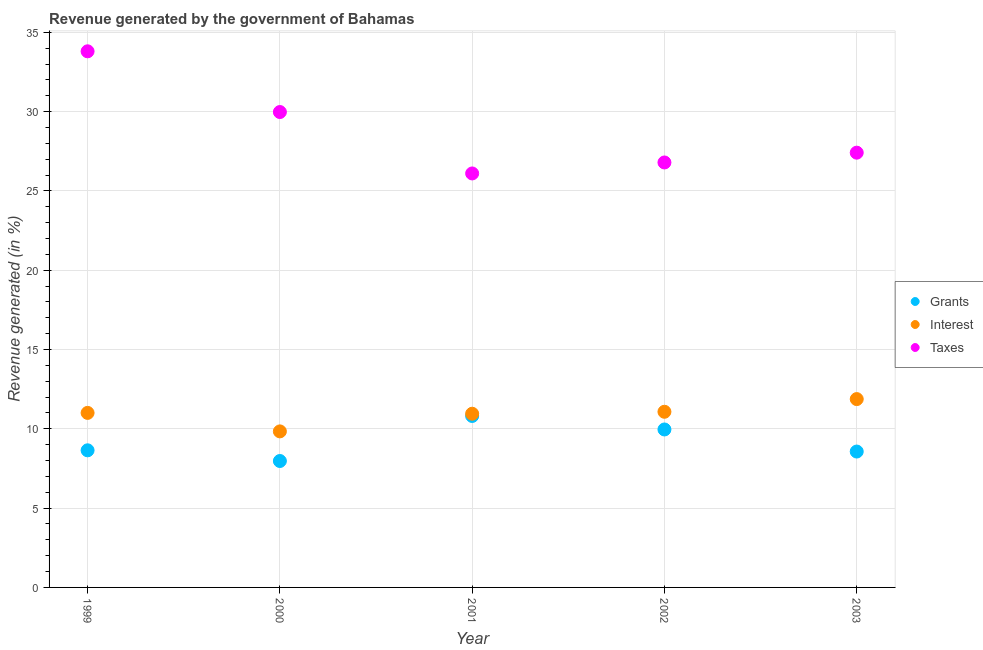What is the percentage of revenue generated by taxes in 2002?
Keep it short and to the point. 26.79. Across all years, what is the maximum percentage of revenue generated by grants?
Offer a terse response. 10.81. Across all years, what is the minimum percentage of revenue generated by grants?
Give a very brief answer. 7.97. What is the total percentage of revenue generated by interest in the graph?
Your answer should be very brief. 54.74. What is the difference between the percentage of revenue generated by taxes in 1999 and that in 2001?
Your answer should be very brief. 7.7. What is the difference between the percentage of revenue generated by grants in 2003 and the percentage of revenue generated by interest in 2001?
Ensure brevity in your answer.  -2.38. What is the average percentage of revenue generated by grants per year?
Your answer should be compact. 9.19. In the year 1999, what is the difference between the percentage of revenue generated by taxes and percentage of revenue generated by interest?
Your answer should be very brief. 22.8. In how many years, is the percentage of revenue generated by taxes greater than 13 %?
Keep it short and to the point. 5. What is the ratio of the percentage of revenue generated by interest in 1999 to that in 2003?
Make the answer very short. 0.93. Is the difference between the percentage of revenue generated by interest in 2001 and 2002 greater than the difference between the percentage of revenue generated by grants in 2001 and 2002?
Your response must be concise. No. What is the difference between the highest and the second highest percentage of revenue generated by taxes?
Ensure brevity in your answer.  3.83. What is the difference between the highest and the lowest percentage of revenue generated by interest?
Ensure brevity in your answer.  2.04. Is it the case that in every year, the sum of the percentage of revenue generated by grants and percentage of revenue generated by interest is greater than the percentage of revenue generated by taxes?
Offer a terse response. No. Does the percentage of revenue generated by interest monotonically increase over the years?
Offer a very short reply. No. How many years are there in the graph?
Keep it short and to the point. 5. What is the difference between two consecutive major ticks on the Y-axis?
Offer a terse response. 5. Are the values on the major ticks of Y-axis written in scientific E-notation?
Keep it short and to the point. No. Where does the legend appear in the graph?
Offer a terse response. Center right. How are the legend labels stacked?
Make the answer very short. Vertical. What is the title of the graph?
Make the answer very short. Revenue generated by the government of Bahamas. Does "Negligence towards kids" appear as one of the legend labels in the graph?
Ensure brevity in your answer.  No. What is the label or title of the X-axis?
Make the answer very short. Year. What is the label or title of the Y-axis?
Keep it short and to the point. Revenue generated (in %). What is the Revenue generated (in %) of Grants in 1999?
Offer a very short reply. 8.64. What is the Revenue generated (in %) in Interest in 1999?
Give a very brief answer. 11. What is the Revenue generated (in %) in Taxes in 1999?
Offer a terse response. 33.8. What is the Revenue generated (in %) of Grants in 2000?
Your answer should be very brief. 7.97. What is the Revenue generated (in %) in Interest in 2000?
Offer a terse response. 9.84. What is the Revenue generated (in %) in Taxes in 2000?
Ensure brevity in your answer.  29.97. What is the Revenue generated (in %) of Grants in 2001?
Offer a very short reply. 10.81. What is the Revenue generated (in %) of Interest in 2001?
Provide a succinct answer. 10.95. What is the Revenue generated (in %) of Taxes in 2001?
Your response must be concise. 26.1. What is the Revenue generated (in %) in Grants in 2002?
Offer a terse response. 9.96. What is the Revenue generated (in %) of Interest in 2002?
Provide a short and direct response. 11.07. What is the Revenue generated (in %) in Taxes in 2002?
Make the answer very short. 26.79. What is the Revenue generated (in %) of Grants in 2003?
Provide a succinct answer. 8.57. What is the Revenue generated (in %) of Interest in 2003?
Keep it short and to the point. 11.87. What is the Revenue generated (in %) in Taxes in 2003?
Provide a succinct answer. 27.41. Across all years, what is the maximum Revenue generated (in %) of Grants?
Ensure brevity in your answer.  10.81. Across all years, what is the maximum Revenue generated (in %) in Interest?
Your answer should be compact. 11.87. Across all years, what is the maximum Revenue generated (in %) of Taxes?
Keep it short and to the point. 33.8. Across all years, what is the minimum Revenue generated (in %) of Grants?
Your answer should be very brief. 7.97. Across all years, what is the minimum Revenue generated (in %) in Interest?
Your response must be concise. 9.84. Across all years, what is the minimum Revenue generated (in %) in Taxes?
Make the answer very short. 26.1. What is the total Revenue generated (in %) of Grants in the graph?
Give a very brief answer. 45.95. What is the total Revenue generated (in %) of Interest in the graph?
Ensure brevity in your answer.  54.74. What is the total Revenue generated (in %) in Taxes in the graph?
Your answer should be compact. 144.08. What is the difference between the Revenue generated (in %) in Grants in 1999 and that in 2000?
Your answer should be compact. 0.67. What is the difference between the Revenue generated (in %) in Interest in 1999 and that in 2000?
Provide a short and direct response. 1.17. What is the difference between the Revenue generated (in %) of Taxes in 1999 and that in 2000?
Your answer should be very brief. 3.83. What is the difference between the Revenue generated (in %) of Grants in 1999 and that in 2001?
Provide a succinct answer. -2.17. What is the difference between the Revenue generated (in %) in Interest in 1999 and that in 2001?
Provide a short and direct response. 0.05. What is the difference between the Revenue generated (in %) of Taxes in 1999 and that in 2001?
Give a very brief answer. 7.7. What is the difference between the Revenue generated (in %) of Grants in 1999 and that in 2002?
Offer a terse response. -1.31. What is the difference between the Revenue generated (in %) in Interest in 1999 and that in 2002?
Your answer should be very brief. -0.07. What is the difference between the Revenue generated (in %) in Taxes in 1999 and that in 2002?
Offer a very short reply. 7.01. What is the difference between the Revenue generated (in %) in Grants in 1999 and that in 2003?
Your answer should be compact. 0.08. What is the difference between the Revenue generated (in %) of Interest in 1999 and that in 2003?
Keep it short and to the point. -0.87. What is the difference between the Revenue generated (in %) in Taxes in 1999 and that in 2003?
Your answer should be very brief. 6.39. What is the difference between the Revenue generated (in %) in Grants in 2000 and that in 2001?
Offer a very short reply. -2.84. What is the difference between the Revenue generated (in %) in Interest in 2000 and that in 2001?
Ensure brevity in your answer.  -1.11. What is the difference between the Revenue generated (in %) in Taxes in 2000 and that in 2001?
Provide a succinct answer. 3.87. What is the difference between the Revenue generated (in %) of Grants in 2000 and that in 2002?
Give a very brief answer. -1.99. What is the difference between the Revenue generated (in %) of Interest in 2000 and that in 2002?
Your answer should be compact. -1.24. What is the difference between the Revenue generated (in %) of Taxes in 2000 and that in 2002?
Give a very brief answer. 3.18. What is the difference between the Revenue generated (in %) of Grants in 2000 and that in 2003?
Your answer should be very brief. -0.6. What is the difference between the Revenue generated (in %) of Interest in 2000 and that in 2003?
Keep it short and to the point. -2.04. What is the difference between the Revenue generated (in %) of Taxes in 2000 and that in 2003?
Provide a succinct answer. 2.56. What is the difference between the Revenue generated (in %) of Grants in 2001 and that in 2002?
Offer a terse response. 0.85. What is the difference between the Revenue generated (in %) of Interest in 2001 and that in 2002?
Give a very brief answer. -0.12. What is the difference between the Revenue generated (in %) in Taxes in 2001 and that in 2002?
Your answer should be compact. -0.69. What is the difference between the Revenue generated (in %) in Grants in 2001 and that in 2003?
Keep it short and to the point. 2.24. What is the difference between the Revenue generated (in %) in Interest in 2001 and that in 2003?
Offer a terse response. -0.92. What is the difference between the Revenue generated (in %) of Taxes in 2001 and that in 2003?
Your answer should be very brief. -1.31. What is the difference between the Revenue generated (in %) in Grants in 2002 and that in 2003?
Offer a very short reply. 1.39. What is the difference between the Revenue generated (in %) in Interest in 2002 and that in 2003?
Keep it short and to the point. -0.8. What is the difference between the Revenue generated (in %) of Taxes in 2002 and that in 2003?
Make the answer very short. -0.62. What is the difference between the Revenue generated (in %) of Grants in 1999 and the Revenue generated (in %) of Interest in 2000?
Offer a terse response. -1.19. What is the difference between the Revenue generated (in %) in Grants in 1999 and the Revenue generated (in %) in Taxes in 2000?
Provide a short and direct response. -21.33. What is the difference between the Revenue generated (in %) in Interest in 1999 and the Revenue generated (in %) in Taxes in 2000?
Offer a very short reply. -18.97. What is the difference between the Revenue generated (in %) in Grants in 1999 and the Revenue generated (in %) in Interest in 2001?
Make the answer very short. -2.31. What is the difference between the Revenue generated (in %) of Grants in 1999 and the Revenue generated (in %) of Taxes in 2001?
Give a very brief answer. -17.46. What is the difference between the Revenue generated (in %) of Interest in 1999 and the Revenue generated (in %) of Taxes in 2001?
Make the answer very short. -15.1. What is the difference between the Revenue generated (in %) in Grants in 1999 and the Revenue generated (in %) in Interest in 2002?
Your answer should be compact. -2.43. What is the difference between the Revenue generated (in %) in Grants in 1999 and the Revenue generated (in %) in Taxes in 2002?
Your answer should be compact. -18.15. What is the difference between the Revenue generated (in %) in Interest in 1999 and the Revenue generated (in %) in Taxes in 2002?
Give a very brief answer. -15.79. What is the difference between the Revenue generated (in %) of Grants in 1999 and the Revenue generated (in %) of Interest in 2003?
Your answer should be compact. -3.23. What is the difference between the Revenue generated (in %) in Grants in 1999 and the Revenue generated (in %) in Taxes in 2003?
Give a very brief answer. -18.77. What is the difference between the Revenue generated (in %) of Interest in 1999 and the Revenue generated (in %) of Taxes in 2003?
Your response must be concise. -16.41. What is the difference between the Revenue generated (in %) of Grants in 2000 and the Revenue generated (in %) of Interest in 2001?
Provide a short and direct response. -2.98. What is the difference between the Revenue generated (in %) in Grants in 2000 and the Revenue generated (in %) in Taxes in 2001?
Give a very brief answer. -18.13. What is the difference between the Revenue generated (in %) in Interest in 2000 and the Revenue generated (in %) in Taxes in 2001?
Your response must be concise. -16.26. What is the difference between the Revenue generated (in %) in Grants in 2000 and the Revenue generated (in %) in Interest in 2002?
Make the answer very short. -3.1. What is the difference between the Revenue generated (in %) in Grants in 2000 and the Revenue generated (in %) in Taxes in 2002?
Offer a terse response. -18.82. What is the difference between the Revenue generated (in %) in Interest in 2000 and the Revenue generated (in %) in Taxes in 2002?
Your response must be concise. -16.96. What is the difference between the Revenue generated (in %) of Grants in 2000 and the Revenue generated (in %) of Interest in 2003?
Give a very brief answer. -3.9. What is the difference between the Revenue generated (in %) of Grants in 2000 and the Revenue generated (in %) of Taxes in 2003?
Keep it short and to the point. -19.44. What is the difference between the Revenue generated (in %) of Interest in 2000 and the Revenue generated (in %) of Taxes in 2003?
Offer a terse response. -17.57. What is the difference between the Revenue generated (in %) of Grants in 2001 and the Revenue generated (in %) of Interest in 2002?
Provide a short and direct response. -0.26. What is the difference between the Revenue generated (in %) in Grants in 2001 and the Revenue generated (in %) in Taxes in 2002?
Make the answer very short. -15.98. What is the difference between the Revenue generated (in %) in Interest in 2001 and the Revenue generated (in %) in Taxes in 2002?
Provide a short and direct response. -15.84. What is the difference between the Revenue generated (in %) of Grants in 2001 and the Revenue generated (in %) of Interest in 2003?
Your answer should be compact. -1.06. What is the difference between the Revenue generated (in %) in Grants in 2001 and the Revenue generated (in %) in Taxes in 2003?
Provide a short and direct response. -16.6. What is the difference between the Revenue generated (in %) in Interest in 2001 and the Revenue generated (in %) in Taxes in 2003?
Offer a very short reply. -16.46. What is the difference between the Revenue generated (in %) in Grants in 2002 and the Revenue generated (in %) in Interest in 2003?
Your answer should be compact. -1.92. What is the difference between the Revenue generated (in %) in Grants in 2002 and the Revenue generated (in %) in Taxes in 2003?
Keep it short and to the point. -17.45. What is the difference between the Revenue generated (in %) of Interest in 2002 and the Revenue generated (in %) of Taxes in 2003?
Your response must be concise. -16.34. What is the average Revenue generated (in %) in Grants per year?
Ensure brevity in your answer.  9.19. What is the average Revenue generated (in %) of Interest per year?
Make the answer very short. 10.95. What is the average Revenue generated (in %) in Taxes per year?
Offer a very short reply. 28.82. In the year 1999, what is the difference between the Revenue generated (in %) of Grants and Revenue generated (in %) of Interest?
Ensure brevity in your answer.  -2.36. In the year 1999, what is the difference between the Revenue generated (in %) in Grants and Revenue generated (in %) in Taxes?
Provide a succinct answer. -25.16. In the year 1999, what is the difference between the Revenue generated (in %) in Interest and Revenue generated (in %) in Taxes?
Offer a very short reply. -22.8. In the year 2000, what is the difference between the Revenue generated (in %) of Grants and Revenue generated (in %) of Interest?
Offer a very short reply. -1.87. In the year 2000, what is the difference between the Revenue generated (in %) of Grants and Revenue generated (in %) of Taxes?
Offer a terse response. -22. In the year 2000, what is the difference between the Revenue generated (in %) in Interest and Revenue generated (in %) in Taxes?
Ensure brevity in your answer.  -20.14. In the year 2001, what is the difference between the Revenue generated (in %) in Grants and Revenue generated (in %) in Interest?
Offer a very short reply. -0.14. In the year 2001, what is the difference between the Revenue generated (in %) in Grants and Revenue generated (in %) in Taxes?
Ensure brevity in your answer.  -15.29. In the year 2001, what is the difference between the Revenue generated (in %) in Interest and Revenue generated (in %) in Taxes?
Your answer should be very brief. -15.15. In the year 2002, what is the difference between the Revenue generated (in %) in Grants and Revenue generated (in %) in Interest?
Your response must be concise. -1.12. In the year 2002, what is the difference between the Revenue generated (in %) in Grants and Revenue generated (in %) in Taxes?
Your response must be concise. -16.83. In the year 2002, what is the difference between the Revenue generated (in %) in Interest and Revenue generated (in %) in Taxes?
Your answer should be compact. -15.72. In the year 2003, what is the difference between the Revenue generated (in %) in Grants and Revenue generated (in %) in Interest?
Your answer should be very brief. -3.31. In the year 2003, what is the difference between the Revenue generated (in %) in Grants and Revenue generated (in %) in Taxes?
Your response must be concise. -18.84. In the year 2003, what is the difference between the Revenue generated (in %) in Interest and Revenue generated (in %) in Taxes?
Ensure brevity in your answer.  -15.54. What is the ratio of the Revenue generated (in %) in Grants in 1999 to that in 2000?
Your answer should be compact. 1.08. What is the ratio of the Revenue generated (in %) of Interest in 1999 to that in 2000?
Offer a very short reply. 1.12. What is the ratio of the Revenue generated (in %) of Taxes in 1999 to that in 2000?
Make the answer very short. 1.13. What is the ratio of the Revenue generated (in %) of Grants in 1999 to that in 2001?
Provide a succinct answer. 0.8. What is the ratio of the Revenue generated (in %) of Interest in 1999 to that in 2001?
Ensure brevity in your answer.  1. What is the ratio of the Revenue generated (in %) in Taxes in 1999 to that in 2001?
Provide a succinct answer. 1.29. What is the ratio of the Revenue generated (in %) in Grants in 1999 to that in 2002?
Ensure brevity in your answer.  0.87. What is the ratio of the Revenue generated (in %) of Interest in 1999 to that in 2002?
Offer a terse response. 0.99. What is the ratio of the Revenue generated (in %) in Taxes in 1999 to that in 2002?
Keep it short and to the point. 1.26. What is the ratio of the Revenue generated (in %) in Grants in 1999 to that in 2003?
Offer a terse response. 1.01. What is the ratio of the Revenue generated (in %) in Interest in 1999 to that in 2003?
Provide a succinct answer. 0.93. What is the ratio of the Revenue generated (in %) in Taxes in 1999 to that in 2003?
Offer a very short reply. 1.23. What is the ratio of the Revenue generated (in %) in Grants in 2000 to that in 2001?
Your answer should be compact. 0.74. What is the ratio of the Revenue generated (in %) in Interest in 2000 to that in 2001?
Provide a succinct answer. 0.9. What is the ratio of the Revenue generated (in %) in Taxes in 2000 to that in 2001?
Provide a short and direct response. 1.15. What is the ratio of the Revenue generated (in %) in Grants in 2000 to that in 2002?
Provide a succinct answer. 0.8. What is the ratio of the Revenue generated (in %) in Interest in 2000 to that in 2002?
Your response must be concise. 0.89. What is the ratio of the Revenue generated (in %) in Taxes in 2000 to that in 2002?
Give a very brief answer. 1.12. What is the ratio of the Revenue generated (in %) of Grants in 2000 to that in 2003?
Offer a very short reply. 0.93. What is the ratio of the Revenue generated (in %) of Interest in 2000 to that in 2003?
Ensure brevity in your answer.  0.83. What is the ratio of the Revenue generated (in %) of Taxes in 2000 to that in 2003?
Make the answer very short. 1.09. What is the ratio of the Revenue generated (in %) of Grants in 2001 to that in 2002?
Your answer should be compact. 1.09. What is the ratio of the Revenue generated (in %) of Interest in 2001 to that in 2002?
Your answer should be very brief. 0.99. What is the ratio of the Revenue generated (in %) of Taxes in 2001 to that in 2002?
Your answer should be very brief. 0.97. What is the ratio of the Revenue generated (in %) in Grants in 2001 to that in 2003?
Make the answer very short. 1.26. What is the ratio of the Revenue generated (in %) of Interest in 2001 to that in 2003?
Offer a terse response. 0.92. What is the ratio of the Revenue generated (in %) of Taxes in 2001 to that in 2003?
Ensure brevity in your answer.  0.95. What is the ratio of the Revenue generated (in %) in Grants in 2002 to that in 2003?
Your answer should be very brief. 1.16. What is the ratio of the Revenue generated (in %) in Interest in 2002 to that in 2003?
Ensure brevity in your answer.  0.93. What is the ratio of the Revenue generated (in %) in Taxes in 2002 to that in 2003?
Your response must be concise. 0.98. What is the difference between the highest and the second highest Revenue generated (in %) of Grants?
Keep it short and to the point. 0.85. What is the difference between the highest and the second highest Revenue generated (in %) in Interest?
Your answer should be compact. 0.8. What is the difference between the highest and the second highest Revenue generated (in %) in Taxes?
Provide a short and direct response. 3.83. What is the difference between the highest and the lowest Revenue generated (in %) of Grants?
Your answer should be compact. 2.84. What is the difference between the highest and the lowest Revenue generated (in %) of Interest?
Your answer should be very brief. 2.04. What is the difference between the highest and the lowest Revenue generated (in %) of Taxes?
Ensure brevity in your answer.  7.7. 